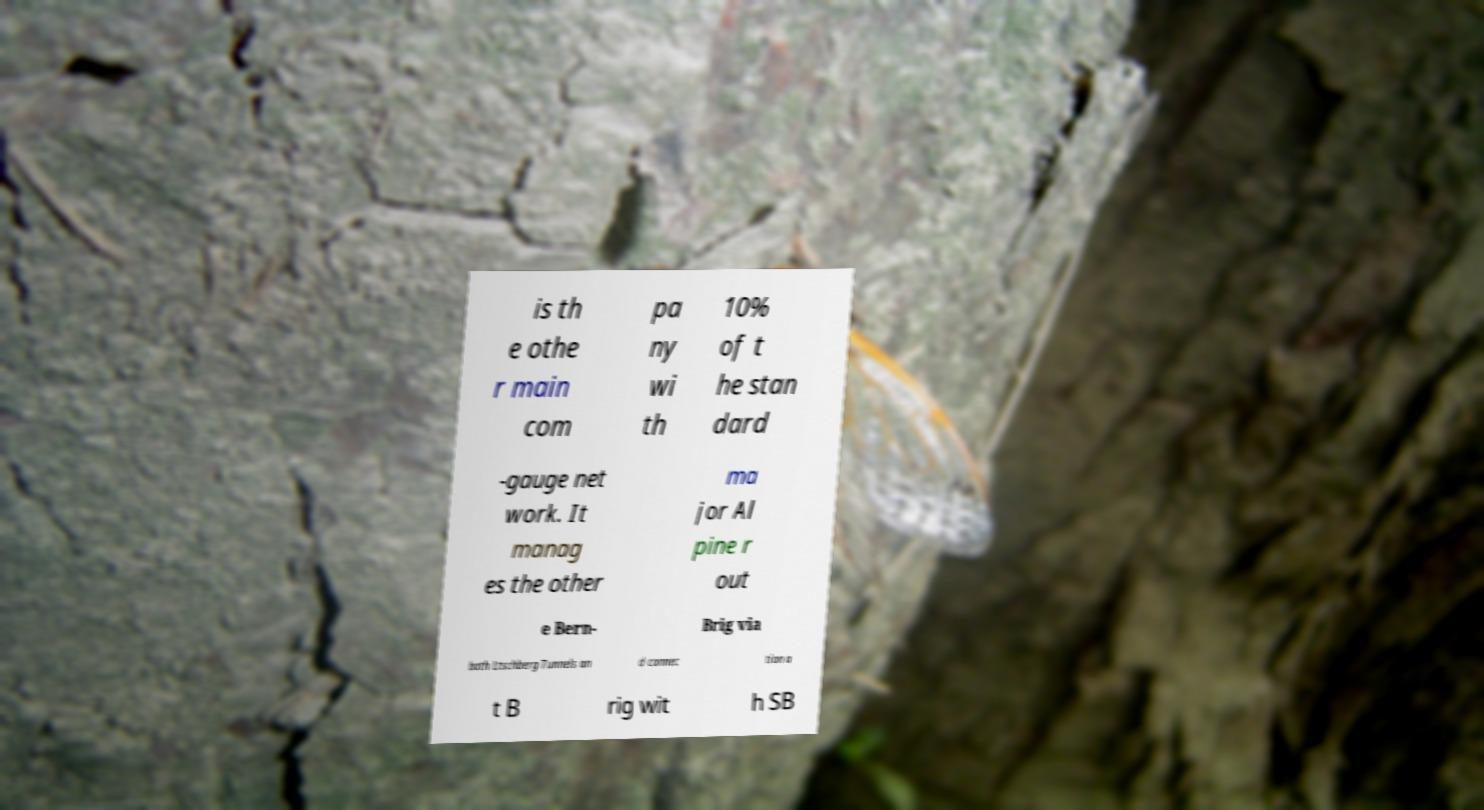Can you accurately transcribe the text from the provided image for me? is th e othe r main com pa ny wi th 10% of t he stan dard -gauge net work. It manag es the other ma jor Al pine r out e Bern- Brig via both Ltschberg Tunnels an d connec tion a t B rig wit h SB 